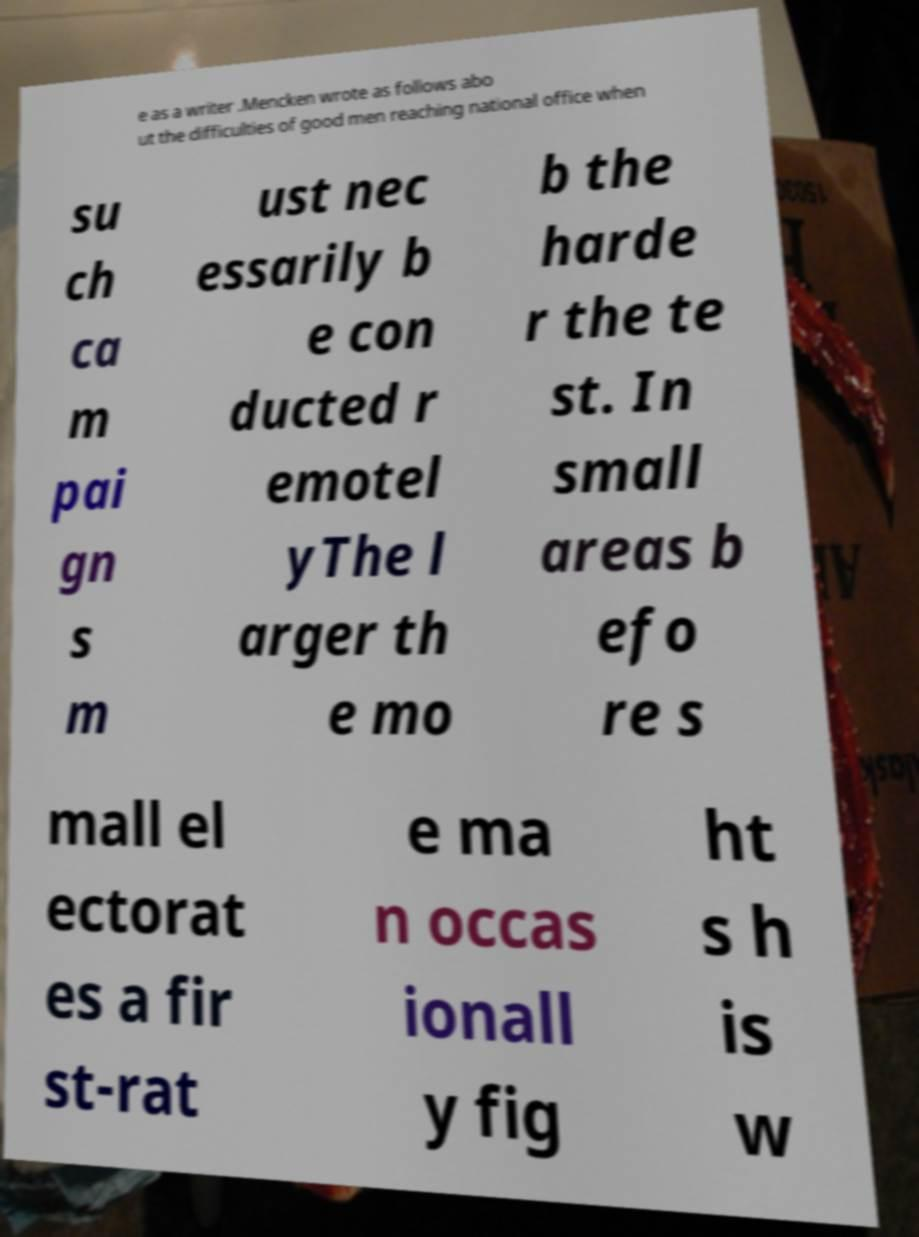What messages or text are displayed in this image? I need them in a readable, typed format. e as a writer .Mencken wrote as follows abo ut the difficulties of good men reaching national office when su ch ca m pai gn s m ust nec essarily b e con ducted r emotel yThe l arger th e mo b the harde r the te st. In small areas b efo re s mall el ectorat es a fir st-rat e ma n occas ionall y fig ht s h is w 